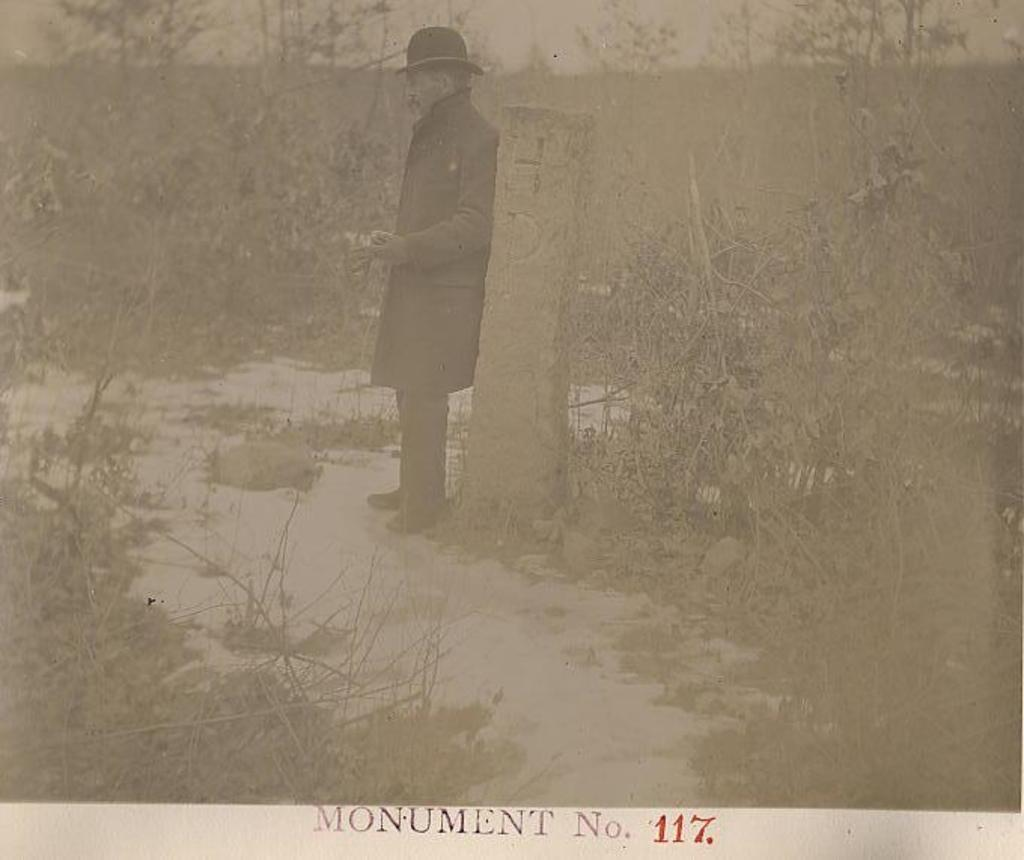What is the main subject of the image? There is a man standing in the center of the image. What is the man wearing in the image? The man is wearing a coat and a hat. What can be seen in the background of the image? There are trees in the background of the image. Are there any architectural features in the image? Yes, there is a pillar in the image. What is the caption of the image? There is no caption present in the image. What is the hour depicted in the image? The image does not show any specific time or hour. 